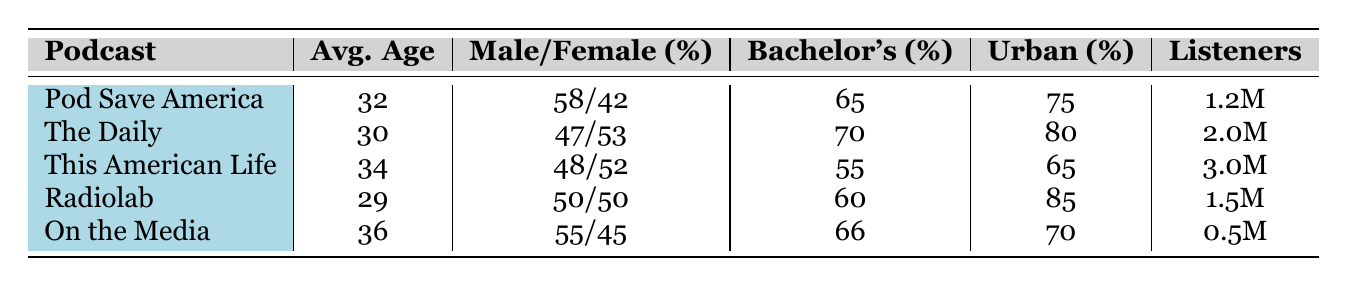What is the average age of "This American Life"? By referring to the table, the average age listed for "This American Life" is 34.
Answer: 34 Which podcast has the highest percentage of listeners in urban areas? Looking at the urban percentage for each podcast, "Radiolab" has the highest with 85%.
Answer: Radiolab What percentage of listeners are male for "On the Media"? The table indicates that for "On the Media," the male percentage is 55%.
Answer: 55% Which podcast has the least number of listeners? The number of listeners for each podcast shows that "On the Media" has the least at 0.5 million.
Answer: On the Media What is the combined percentage of listeners who have a bachelor's degree for "Pod Save America" and "The Daily"? For "Pod Save America," the bachelor's degree percentage is 65%, and for "The Daily," it is 70%. Summing these gives 65 + 70 = 135%.
Answer: 135% Are there more female or male listeners in "Radiolab"? The gender distribution indicates a 50/50 split, so neither gender has more listeners.
Answer: No What is the average age of the podcasts listed? To find the average age, sum the average ages (32 + 30 + 34 + 29 + 36 = 161) and divide by the number of podcasts (5). The average is 161/5 = 32.2.
Answer: 32.2 Which podcast has a higher percentage of female listeners: "The Daily" or "This American Life"? "The Daily" has 53% female listeners while "This American Life" has 52%; thus, "The Daily" has a higher percentage.
Answer: The Daily How many total listeners are there across all podcasts? Adding the number of listeners for each podcast (1.2M + 2.0M + 3.0M + 1.5M + 0.5M = 8.2M) provides the total.
Answer: 8.2 million Is the average age of listeners for "Pod Save America" older than for "Radiolab"? "Pod Save America" has an average age of 32, and "Radiolab" has an average age of 29, indicating that "Pod Save America" listeners are older.
Answer: Yes 